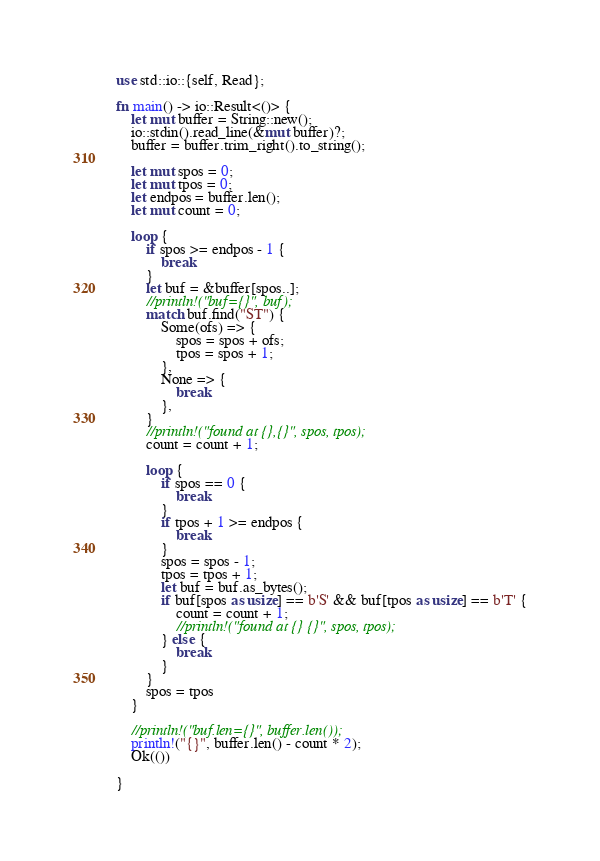Convert code to text. <code><loc_0><loc_0><loc_500><loc_500><_Rust_>use std::io::{self, Read};

fn main() -> io::Result<()> {
    let mut buffer = String::new();
    io::stdin().read_line(&mut buffer)?;
    buffer = buffer.trim_right().to_string();

    let mut spos = 0;
    let mut tpos = 0;
    let endpos = buffer.len();
    let mut count = 0;

    loop {
        if spos >= endpos - 1 {
            break
        }
        let buf = &buffer[spos..];
        //println!("buf={}", buf);
        match buf.find("ST") {
            Some(ofs) => {
                spos = spos + ofs;
                tpos = spos + 1;
            },
            None => {
                break
            },
        }
        //println!("found at {},{}", spos, tpos);
        count = count + 1;

        loop {
            if spos == 0 {
                break
            }
            if tpos + 1 >= endpos {
                break
            }
            spos = spos - 1;
            tpos = tpos + 1;
            let buf = buf.as_bytes();
            if buf[spos as usize] == b'S' && buf[tpos as usize] == b'T' {
                count = count + 1;
                //println!("found at {} {}", spos, tpos);
            } else {
                break
            }
        }
        spos = tpos
    }

    //println!("buf.len={}", buffer.len());
    println!("{}", buffer.len() - count * 2);
    Ok(())

} 
</code> 